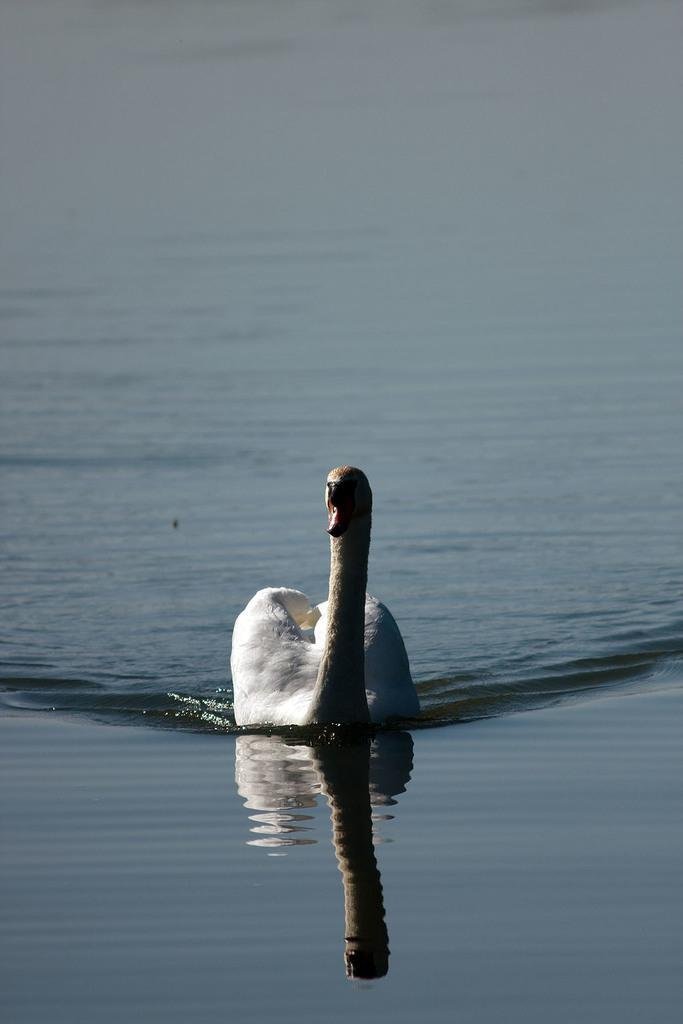In one or two sentences, can you explain what this image depicts? In this picture we observe a white swan which is swimming in the river. 